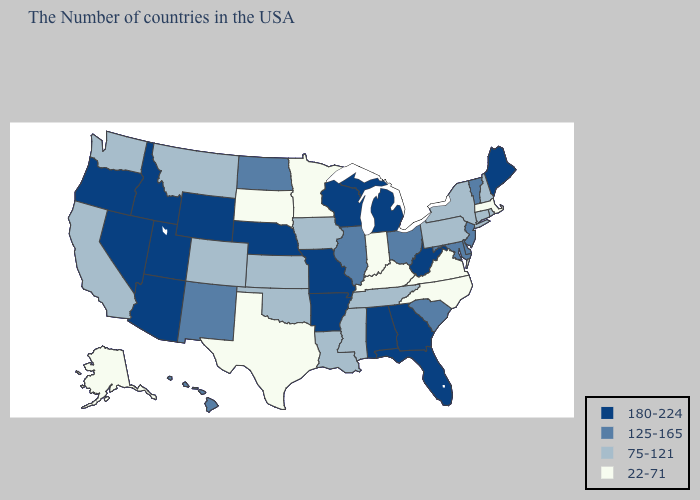Does the map have missing data?
Give a very brief answer. No. What is the lowest value in states that border Missouri?
Concise answer only. 22-71. What is the highest value in the USA?
Short answer required. 180-224. What is the value of Kansas?
Quick response, please. 75-121. What is the lowest value in the MidWest?
Give a very brief answer. 22-71. What is the value of New York?
Write a very short answer. 75-121. Name the states that have a value in the range 22-71?
Answer briefly. Massachusetts, Virginia, North Carolina, Kentucky, Indiana, Minnesota, Texas, South Dakota, Alaska. Name the states that have a value in the range 22-71?
Quick response, please. Massachusetts, Virginia, North Carolina, Kentucky, Indiana, Minnesota, Texas, South Dakota, Alaska. What is the value of Michigan?
Short answer required. 180-224. Which states hav the highest value in the Northeast?
Answer briefly. Maine. Among the states that border Kansas , does Nebraska have the lowest value?
Be succinct. No. What is the value of Maryland?
Concise answer only. 125-165. What is the highest value in states that border Utah?
Quick response, please. 180-224. What is the value of Wisconsin?
Concise answer only. 180-224. 